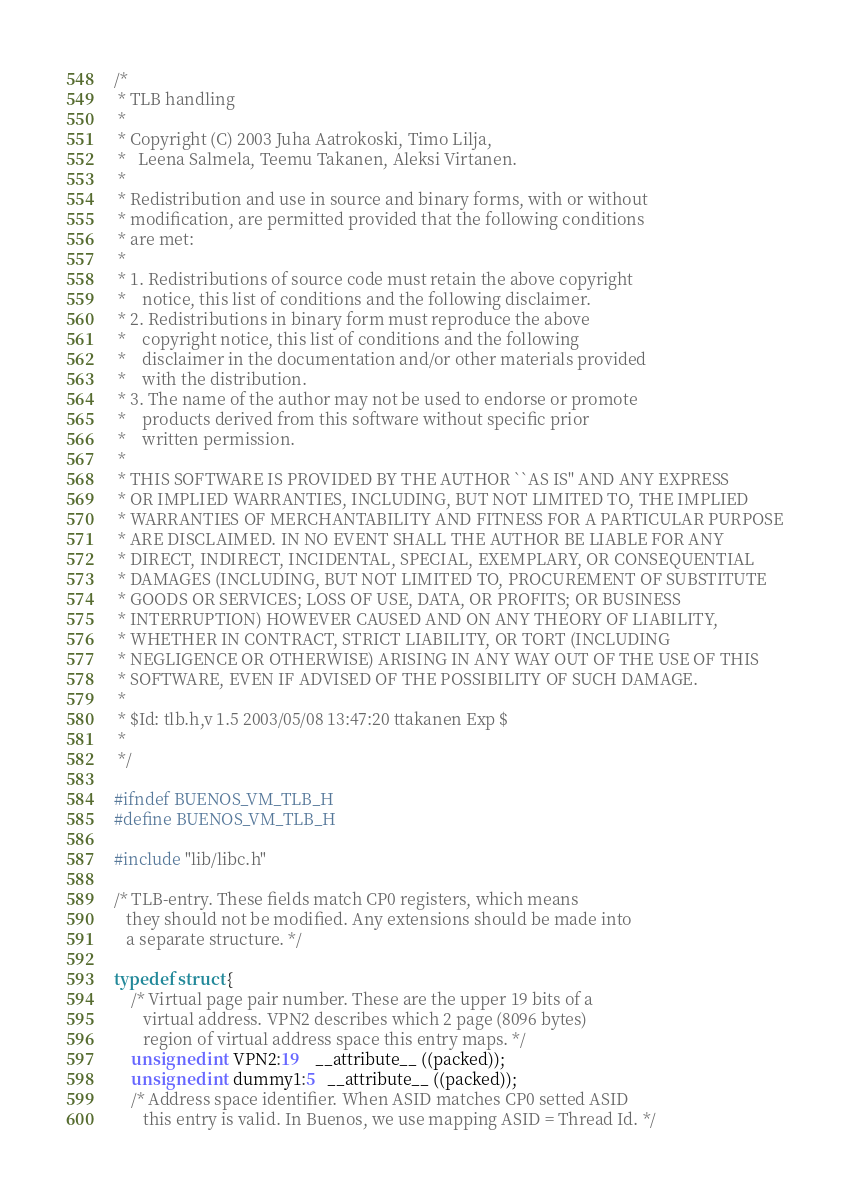Convert code to text. <code><loc_0><loc_0><loc_500><loc_500><_C_>/*
 * TLB handling
 *
 * Copyright (C) 2003 Juha Aatrokoski, Timo Lilja,
 *   Leena Salmela, Teemu Takanen, Aleksi Virtanen.
 *
 * Redistribution and use in source and binary forms, with or without
 * modification, are permitted provided that the following conditions
 * are met:
 *
 * 1. Redistributions of source code must retain the above copyright
 *    notice, this list of conditions and the following disclaimer.
 * 2. Redistributions in binary form must reproduce the above
 *    copyright notice, this list of conditions and the following
 *    disclaimer in the documentation and/or other materials provided
 *    with the distribution.
 * 3. The name of the author may not be used to endorse or promote
 *    products derived from this software without specific prior
 *    written permission.
 *
 * THIS SOFTWARE IS PROVIDED BY THE AUTHOR ``AS IS'' AND ANY EXPRESS
 * OR IMPLIED WARRANTIES, INCLUDING, BUT NOT LIMITED TO, THE IMPLIED
 * WARRANTIES OF MERCHANTABILITY AND FITNESS FOR A PARTICULAR PURPOSE
 * ARE DISCLAIMED. IN NO EVENT SHALL THE AUTHOR BE LIABLE FOR ANY
 * DIRECT, INDIRECT, INCIDENTAL, SPECIAL, EXEMPLARY, OR CONSEQUENTIAL
 * DAMAGES (INCLUDING, BUT NOT LIMITED TO, PROCUREMENT OF SUBSTITUTE
 * GOODS OR SERVICES; LOSS OF USE, DATA, OR PROFITS; OR BUSINESS
 * INTERRUPTION) HOWEVER CAUSED AND ON ANY THEORY OF LIABILITY,
 * WHETHER IN CONTRACT, STRICT LIABILITY, OR TORT (INCLUDING
 * NEGLIGENCE OR OTHERWISE) ARISING IN ANY WAY OUT OF THE USE OF THIS
 * SOFTWARE, EVEN IF ADVISED OF THE POSSIBILITY OF SUCH DAMAGE.
 *
 * $Id: tlb.h,v 1.5 2003/05/08 13:47:20 ttakanen Exp $
 *
 */

#ifndef BUENOS_VM_TLB_H
#define BUENOS_VM_TLB_H

#include "lib/libc.h"

/* TLB-entry. These fields match CP0 registers, which means
   they should not be modified. Any extensions should be made into
   a separate structure. */

typedef struct {
    /* Virtual page pair number. These are the upper 19 bits of a 
       virtual address. VPN2 describes which 2 page (8096 bytes)
       region of virtual address space this entry maps. */
    unsigned int VPN2:19    __attribute__ ((packed));
    unsigned int dummy1:5   __attribute__ ((packed));
    /* Address space identifier. When ASID matches CP0 setted ASID
       this entry is valid. In Buenos, we use mapping ASID = Thread Id. */</code> 